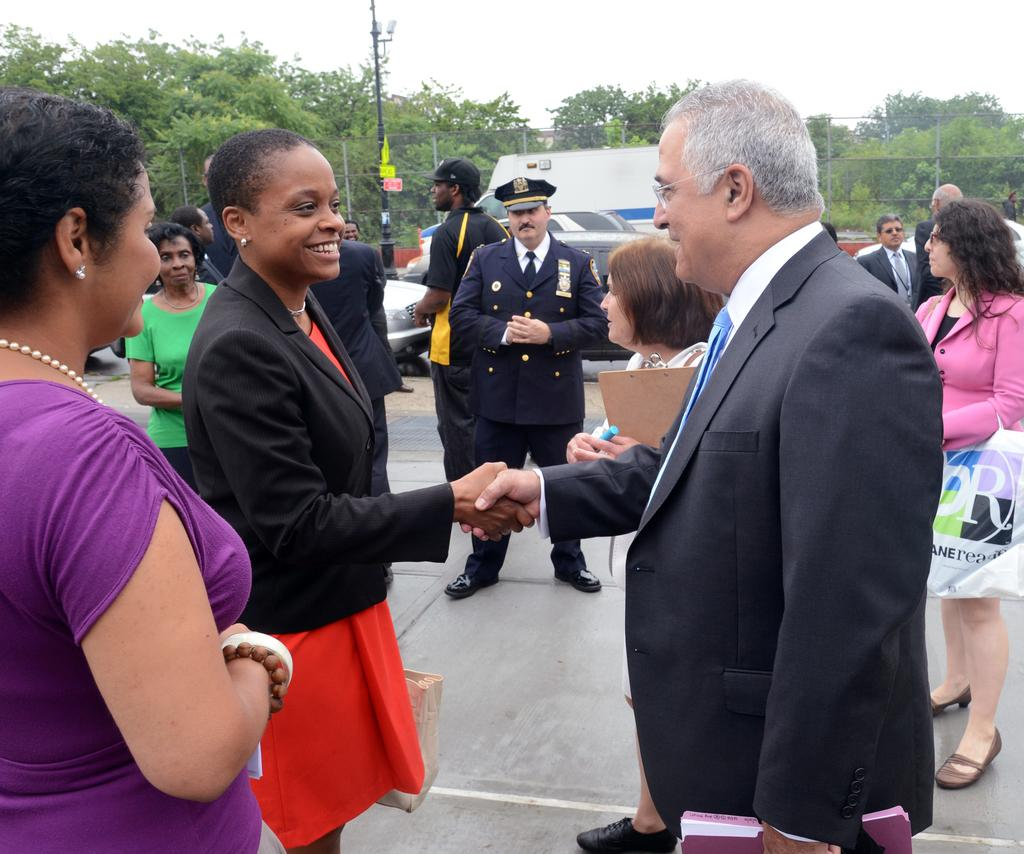What is the main subject in the foreground of the image? There is a group of people in the foreground of the image. What can be seen in the center of the image? There are vehicles, a pole, trees, fencing, a wall, and other objects in the center of the image. What is visible at the top of the image? The sky is visible at the top of the image. How many feet are visible on the people in the image? It is impossible to determine the exact number of feet visible on the people in the image, as the number of feet would depend on the number of people and their positions in the image. --- Facts: 1. There is a person holding a book in the image. 2. The person is sitting on a chair. 3. There is a table in the image. 4. The table has a lamp on it. 5. The background of the image is a room. Absurd Topics: fish, ocean, waves Conversation: What is the person in the image holding? The person in the image is holding a book. What is the person's position in the image? The person is sitting on a chair. What other furniture is present in the image? There is a table in the image. What is on the table? The table has a lamp on it. What is the setting of the image? The background of the image is a room. Reasoning: Let's think step by step in order to produce the conversation. We start by identifying the main subject in the image, which is the person holding a book. Then, we describe the person's position and the presence of a table and a lamp. Finally, we mention the setting of the image, which is a room. Each question is designed to elicit a specific detail about the image that is known from the provided facts. Absurd Question/Answer: What type of fish can be seen swimming in the ocean in the image? There is no ocean or fish present in the image; it features a person sitting on a chair holding a book in a room. 